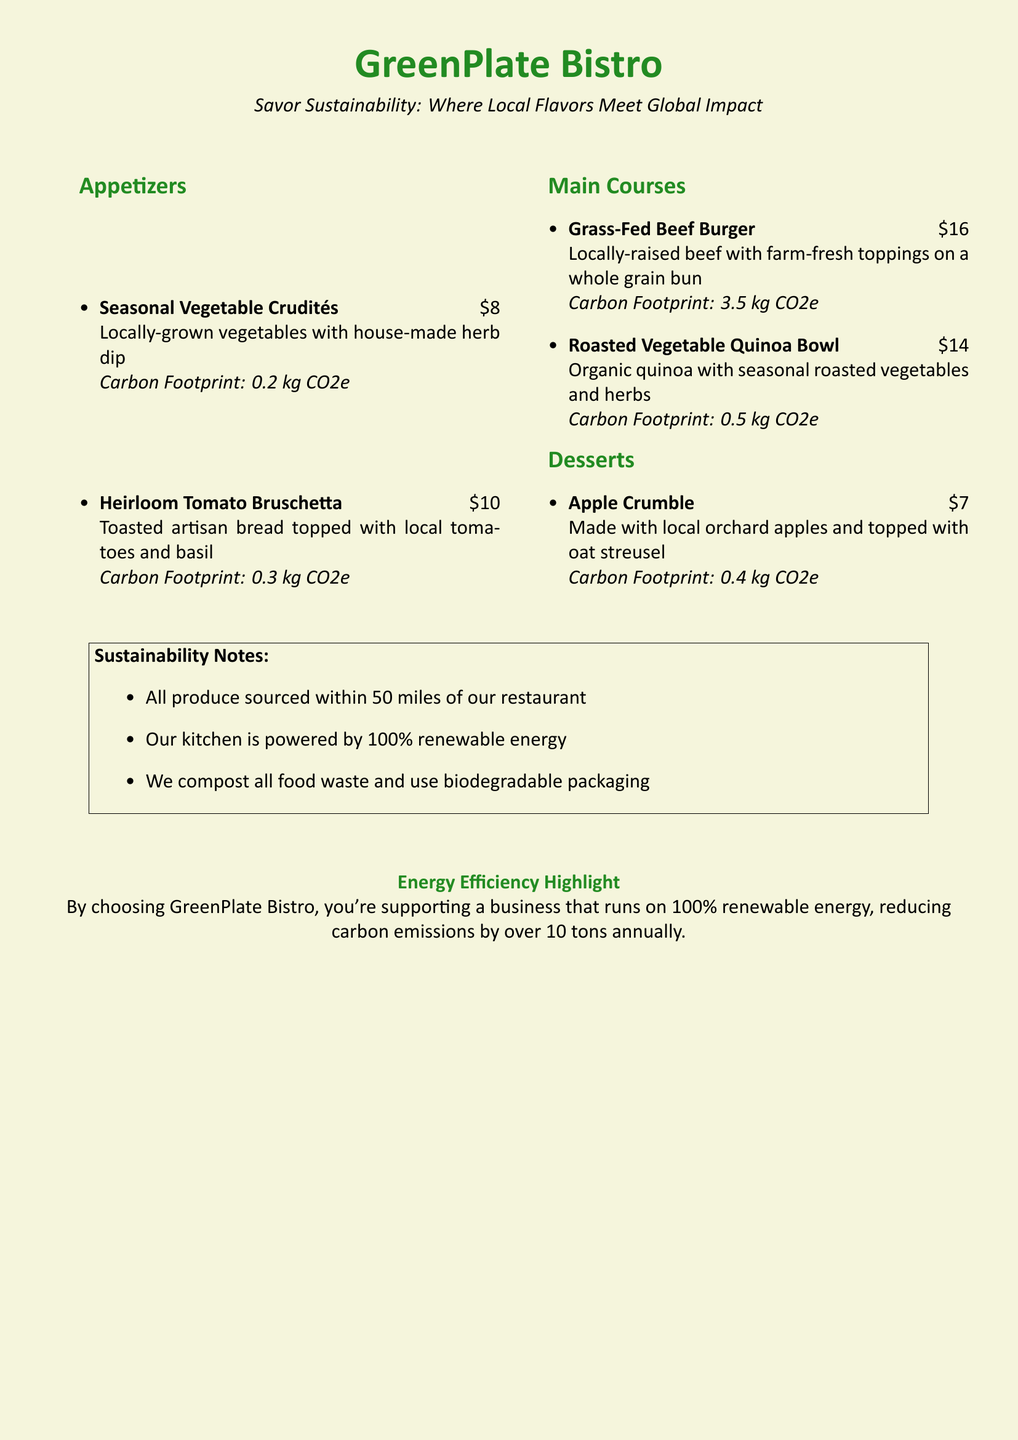what is the price of the Roasted Vegetable Quinoa Bowl? The price of the Roasted Vegetable Quinoa Bowl is found in the main courses section of the menu.
Answer: $14 what is the carbon footprint of the Heirloom Tomato Bruschetta? The carbon footprint can be found next to each dish in the menu.
Answer: 0.3 kg CO2e how many appetizer options are listed in the menu? The number of appetizer options can be counted in the appetizers section of the menu.
Answer: 2 what local ingredient is used in the Apple Crumble? The local ingredient mentioned in the dessert section for the Apple Crumble is identified in the description.
Answer: orchard apples how far are all produce sources located from the restaurant? The distance for all produce sources is specified in the sustainability notes of the document.
Answer: 50 miles which meal has the highest carbon footprint? The meal with the highest carbon footprint can be determined by comparing the carbon footprints of all main courses.
Answer: Grass-Fed Beef Burger how does GreenPlate Bistro manage its kitchen energy? The method of energy management for the kitchen is specified in the restaurant's highlights.
Answer: 100% renewable energy what type of packaging is used at GreenPlate Bistro? The type of packaging is mentioned in the sustainability notes section.
Answer: biodegradable packaging how many tons of carbon emissions does GreenPlate Bistro reduce annually? The total annual carbon emissions reduction is stated in the energy efficiency highlight.
Answer: over 10 tons 